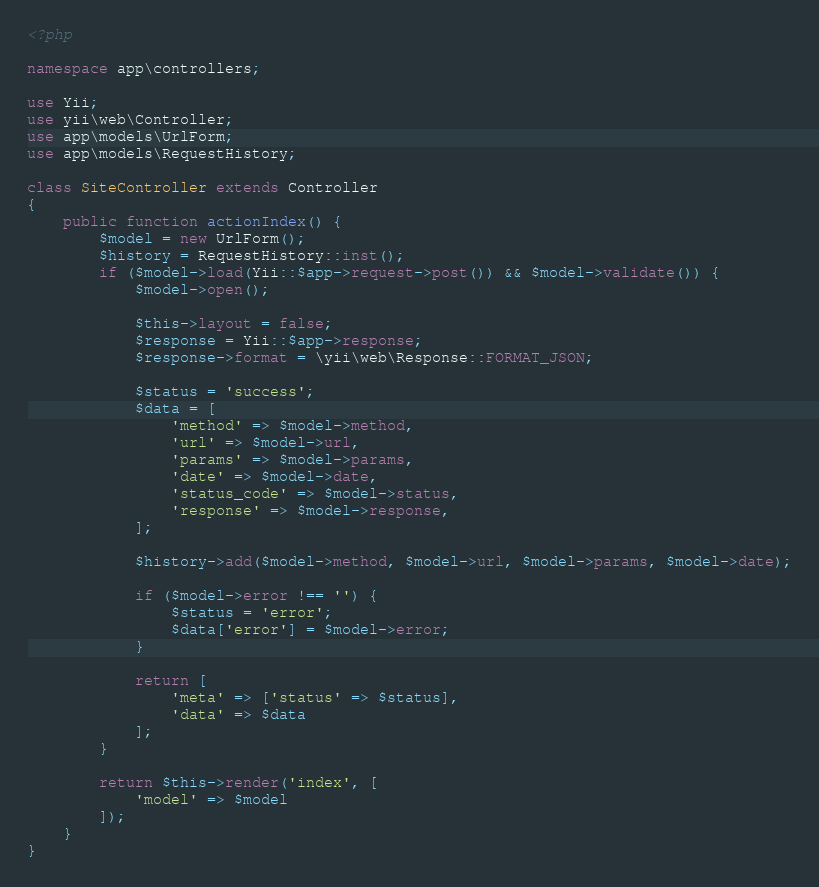Convert code to text. <code><loc_0><loc_0><loc_500><loc_500><_PHP_><?php

namespace app\controllers;

use Yii;
use yii\web\Controller;
use app\models\UrlForm;
use app\models\RequestHistory;

class SiteController extends Controller
{
    public function actionIndex() {
        $model = new UrlForm();
        $history = RequestHistory::inst();
        if ($model->load(Yii::$app->request->post()) && $model->validate()) {
            $model->open();
            
            $this->layout = false;
            $response = Yii::$app->response;
            $response->format = \yii\web\Response::FORMAT_JSON;
            
            $status = 'success';
            $data = [
                'method' => $model->method,
                'url' => $model->url,
                'params' => $model->params,
                'date' => $model->date,
                'status_code' => $model->status,
                'response' => $model->response,
            ];
            
            $history->add($model->method, $model->url, $model->params, $model->date);
            
            if ($model->error !== '') {
                $status = 'error';
                $data['error'] = $model->error;
            }
                
            return [
                'meta' => ['status' => $status],
                'data' => $data
            ];
        }
        
        return $this->render('index', [
            'model' => $model
        ]);
    }
}
</code> 